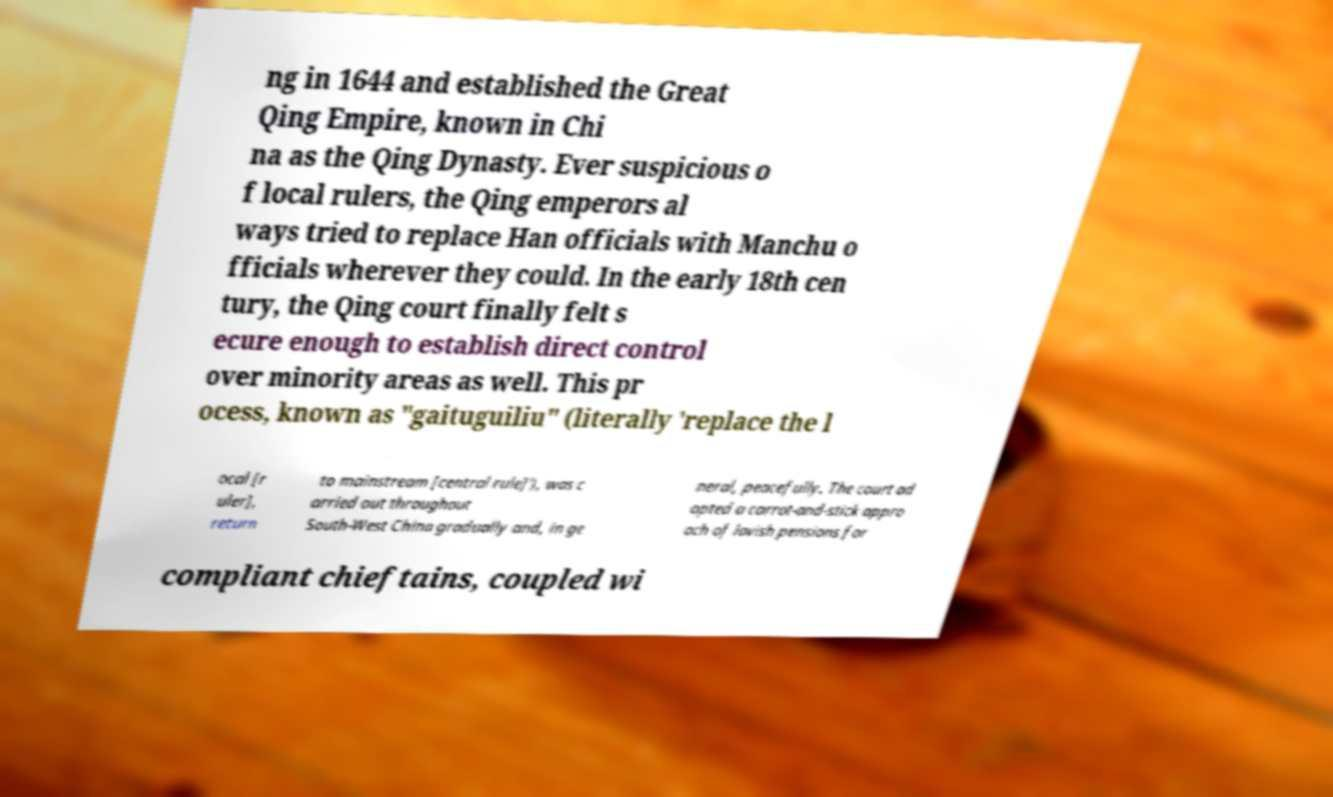There's text embedded in this image that I need extracted. Can you transcribe it verbatim? ng in 1644 and established the Great Qing Empire, known in Chi na as the Qing Dynasty. Ever suspicious o f local rulers, the Qing emperors al ways tried to replace Han officials with Manchu o fficials wherever they could. In the early 18th cen tury, the Qing court finally felt s ecure enough to establish direct control over minority areas as well. This pr ocess, known as "gaituguiliu" (literally 'replace the l ocal [r uler], return to mainstream [central rule]'), was c arried out throughout South-West China gradually and, in ge neral, peacefully. The court ad opted a carrot-and-stick appro ach of lavish pensions for compliant chieftains, coupled wi 